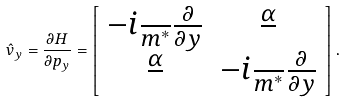<formula> <loc_0><loc_0><loc_500><loc_500>\hat { v } _ { y } = \frac { \partial H } { \partial p _ { y } } = \left [ \begin{array} { c c } - i \frac { } { m ^ { * } } \frac { \partial } { \partial y } & \frac { \alpha } { } \\ \frac { \alpha } { } & - i \frac { } { m ^ { * } } \frac { \partial } { \partial y } \end{array} \right ] .</formula> 